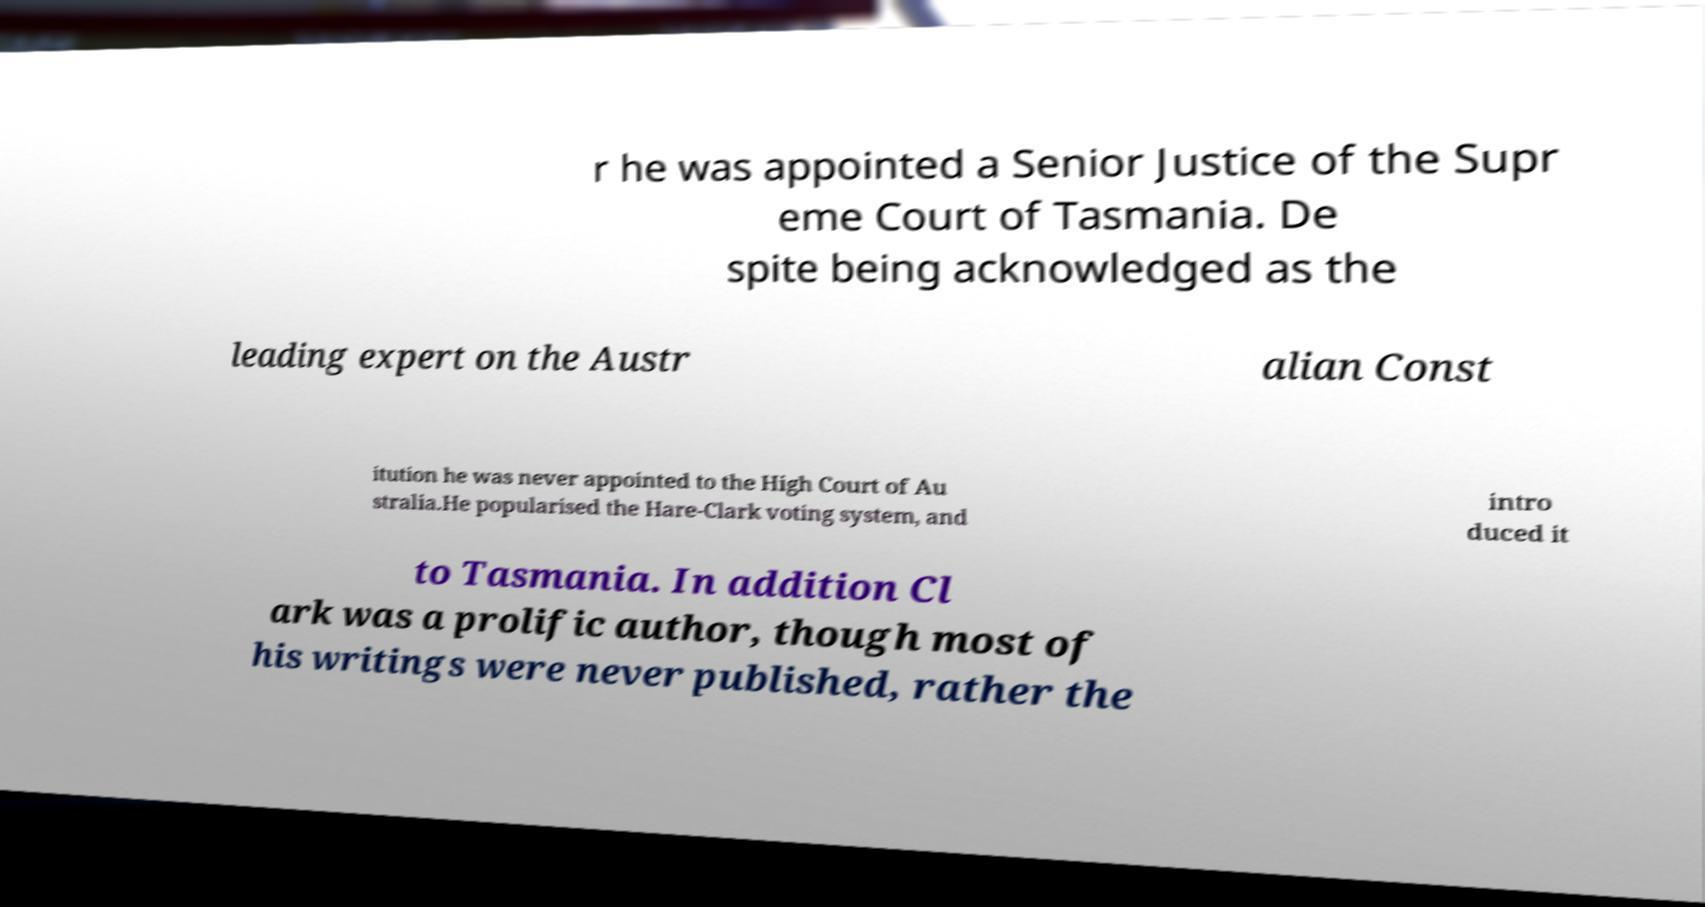Can you accurately transcribe the text from the provided image for me? r he was appointed a Senior Justice of the Supr eme Court of Tasmania. De spite being acknowledged as the leading expert on the Austr alian Const itution he was never appointed to the High Court of Au stralia.He popularised the Hare-Clark voting system, and intro duced it to Tasmania. In addition Cl ark was a prolific author, though most of his writings were never published, rather the 